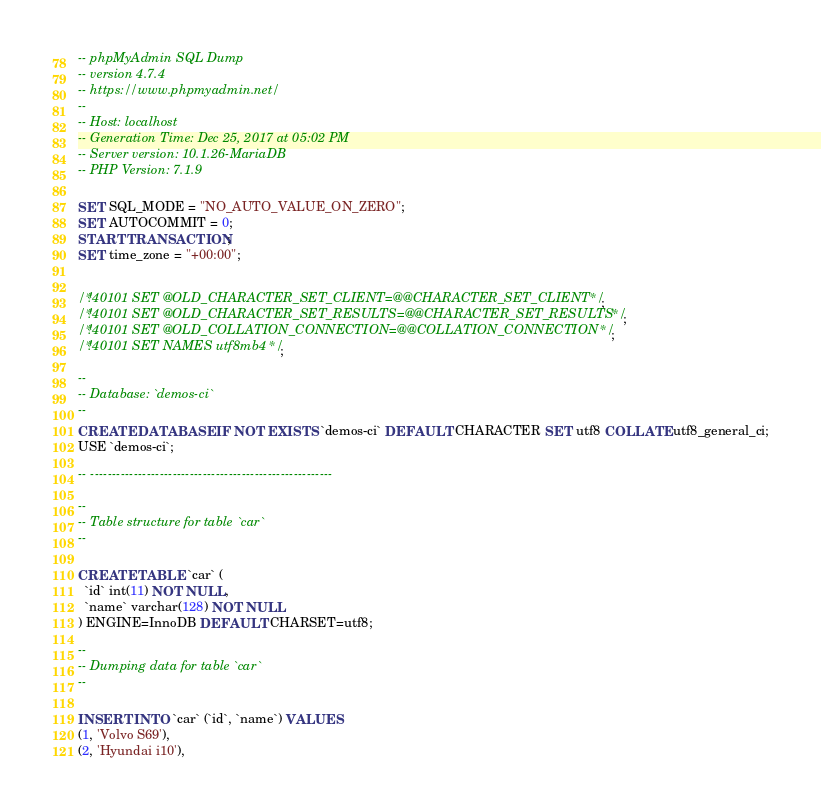<code> <loc_0><loc_0><loc_500><loc_500><_SQL_>-- phpMyAdmin SQL Dump
-- version 4.7.4
-- https://www.phpmyadmin.net/
--
-- Host: localhost
-- Generation Time: Dec 25, 2017 at 05:02 PM
-- Server version: 10.1.26-MariaDB
-- PHP Version: 7.1.9

SET SQL_MODE = "NO_AUTO_VALUE_ON_ZERO";
SET AUTOCOMMIT = 0;
START TRANSACTION;
SET time_zone = "+00:00";


/*!40101 SET @OLD_CHARACTER_SET_CLIENT=@@CHARACTER_SET_CLIENT */;
/*!40101 SET @OLD_CHARACTER_SET_RESULTS=@@CHARACTER_SET_RESULTS */;
/*!40101 SET @OLD_COLLATION_CONNECTION=@@COLLATION_CONNECTION */;
/*!40101 SET NAMES utf8mb4 */;

--
-- Database: `demos-ci`
--
CREATE DATABASE IF NOT EXISTS `demos-ci` DEFAULT CHARACTER SET utf8 COLLATE utf8_general_ci;
USE `demos-ci`;

-- --------------------------------------------------------

--
-- Table structure for table `car`
--

CREATE TABLE `car` (
  `id` int(11) NOT NULL,
  `name` varchar(128) NOT NULL
) ENGINE=InnoDB DEFAULT CHARSET=utf8;

--
-- Dumping data for table `car`
--

INSERT INTO `car` (`id`, `name`) VALUES
(1, 'Volvo S69'),
(2, 'Hyundai i10'),</code> 